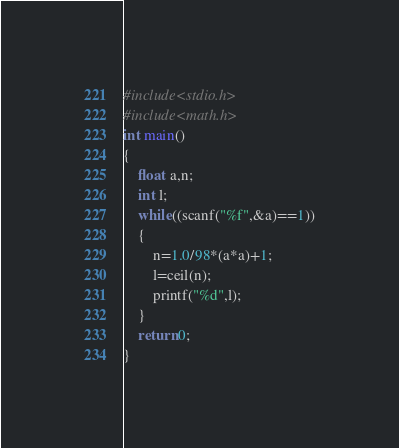<code> <loc_0><loc_0><loc_500><loc_500><_C_>#include<stdio.h>
#include<math.h>
int main()
{
    float a,n;
    int l;
    while((scanf("%f",&a)==1))
    {
        n=1.0/98*(a*a)+1;
        l=ceil(n);
        printf("%d",l);
    }
    return 0;
}</code> 